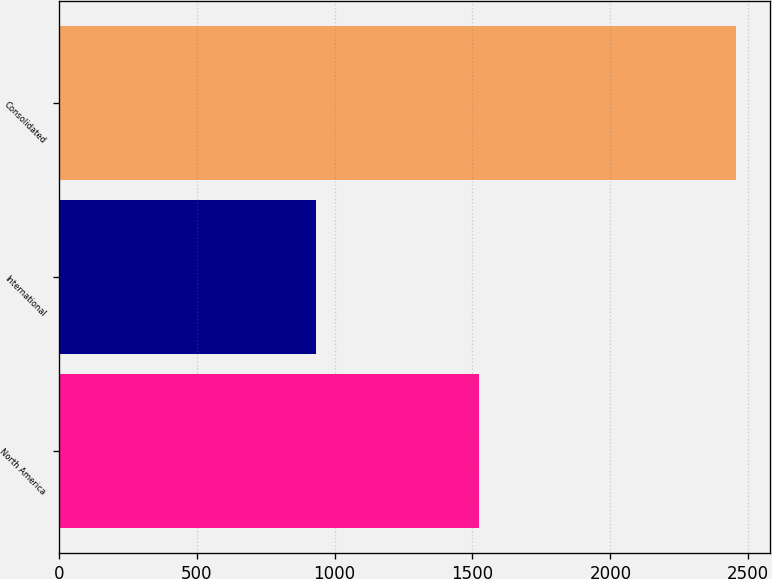Convert chart. <chart><loc_0><loc_0><loc_500><loc_500><bar_chart><fcel>North America<fcel>International<fcel>Consolidated<nl><fcel>1525<fcel>931<fcel>2456<nl></chart> 